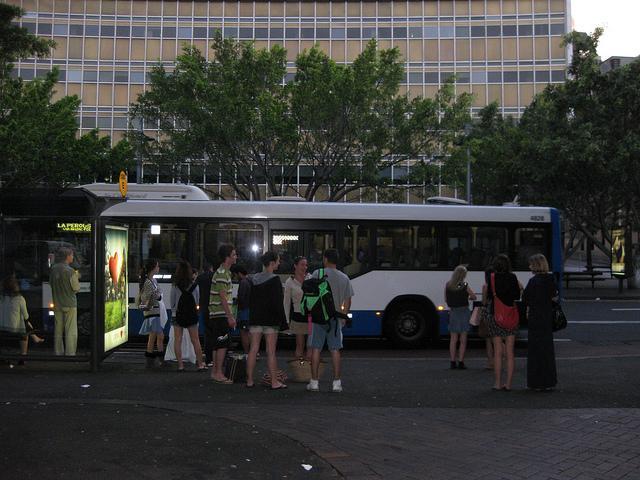How many people are there?
Give a very brief answer. 8. How many buses are there?
Give a very brief answer. 1. How many bears are there?
Give a very brief answer. 0. 